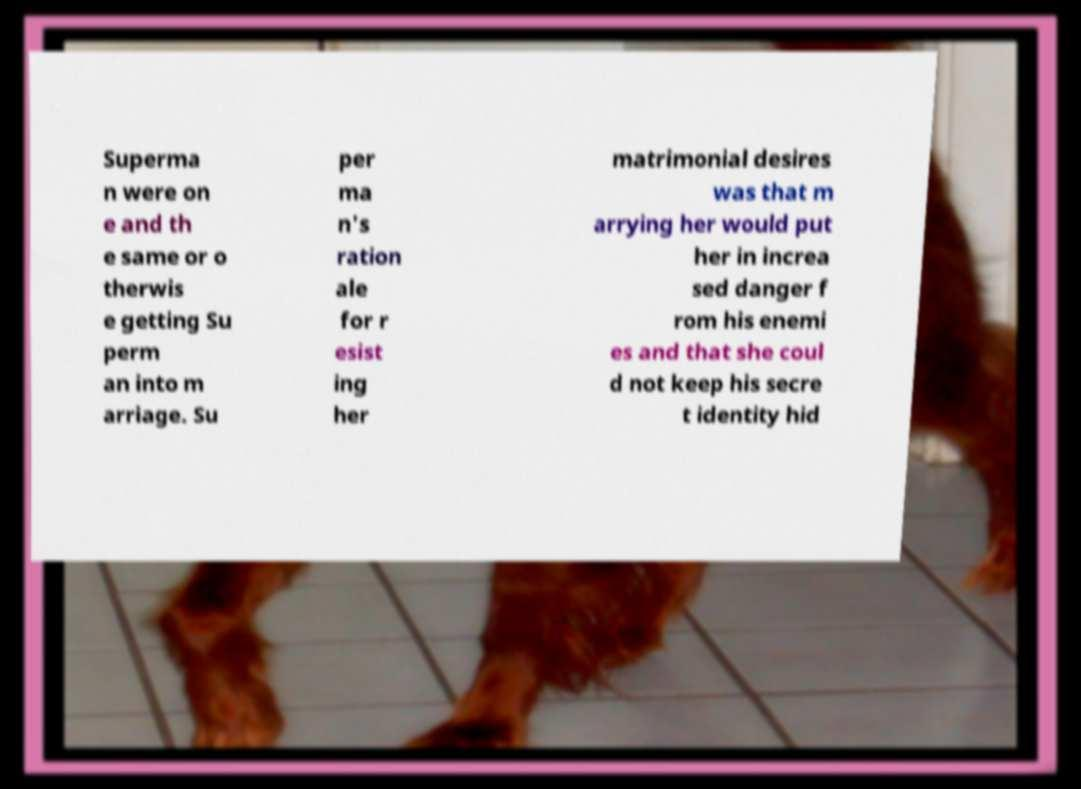Can you read and provide the text displayed in the image?This photo seems to have some interesting text. Can you extract and type it out for me? Superma n were on e and th e same or o therwis e getting Su perm an into m arriage. Su per ma n's ration ale for r esist ing her matrimonial desires was that m arrying her would put her in increa sed danger f rom his enemi es and that she coul d not keep his secre t identity hid 